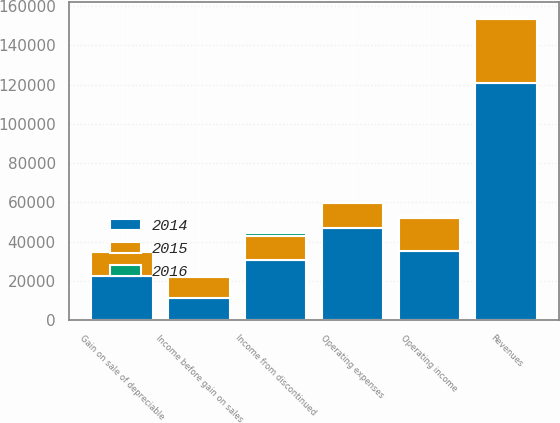Convert chart. <chart><loc_0><loc_0><loc_500><loc_500><stacked_bar_chart><ecel><fcel>Revenues<fcel>Operating expenses<fcel>Operating income<fcel>Income before gain on sales<fcel>Gain on sale of depreciable<fcel>Income from discontinued<nl><fcel>2016<fcel>983<fcel>8<fcel>991<fcel>991<fcel>1016<fcel>2007<nl><fcel>2015<fcel>32549<fcel>12498<fcel>16534<fcel>10939<fcel>11784.5<fcel>11784.5<nl><fcel>2014<fcel>120884<fcel>47123<fcel>35419<fcel>11071<fcel>22763<fcel>30865<nl></chart> 